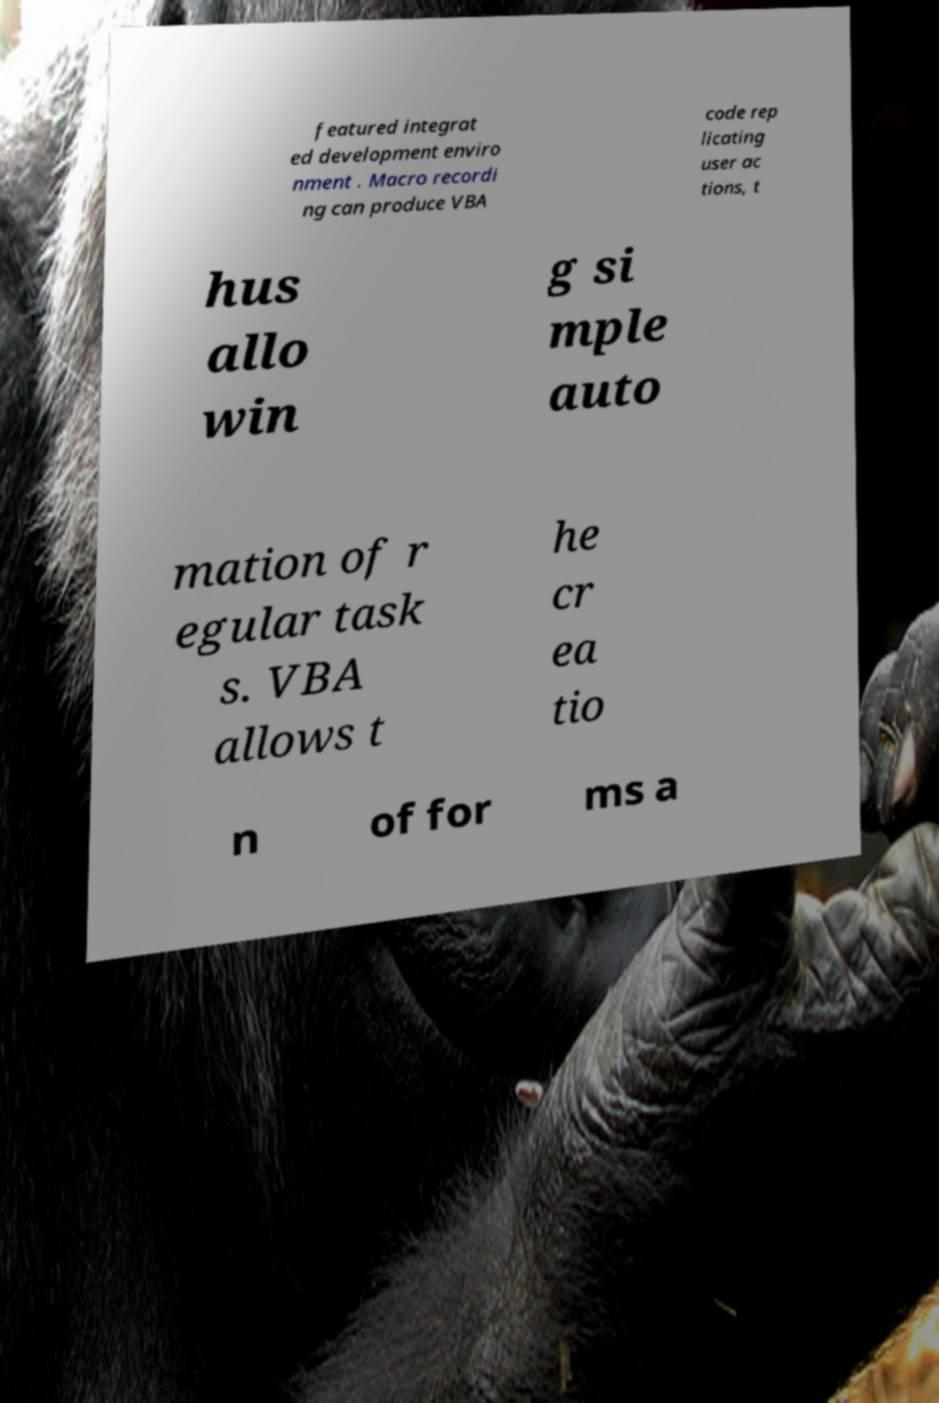Can you read and provide the text displayed in the image?This photo seems to have some interesting text. Can you extract and type it out for me? featured integrat ed development enviro nment . Macro recordi ng can produce VBA code rep licating user ac tions, t hus allo win g si mple auto mation of r egular task s. VBA allows t he cr ea tio n of for ms a 